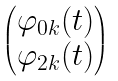Convert formula to latex. <formula><loc_0><loc_0><loc_500><loc_500>\begin{pmatrix} \varphi _ { 0 { k } } ( t ) \\ \varphi _ { 2 { k } } ( t ) \end{pmatrix}</formula> 